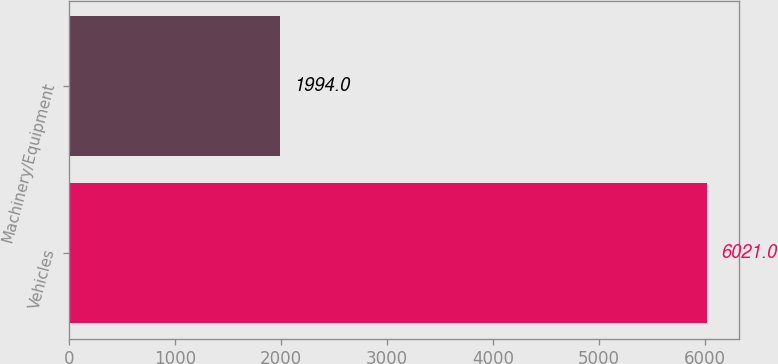Convert chart. <chart><loc_0><loc_0><loc_500><loc_500><bar_chart><fcel>Vehicles<fcel>Machinery/Equipment<nl><fcel>6021<fcel>1994<nl></chart> 